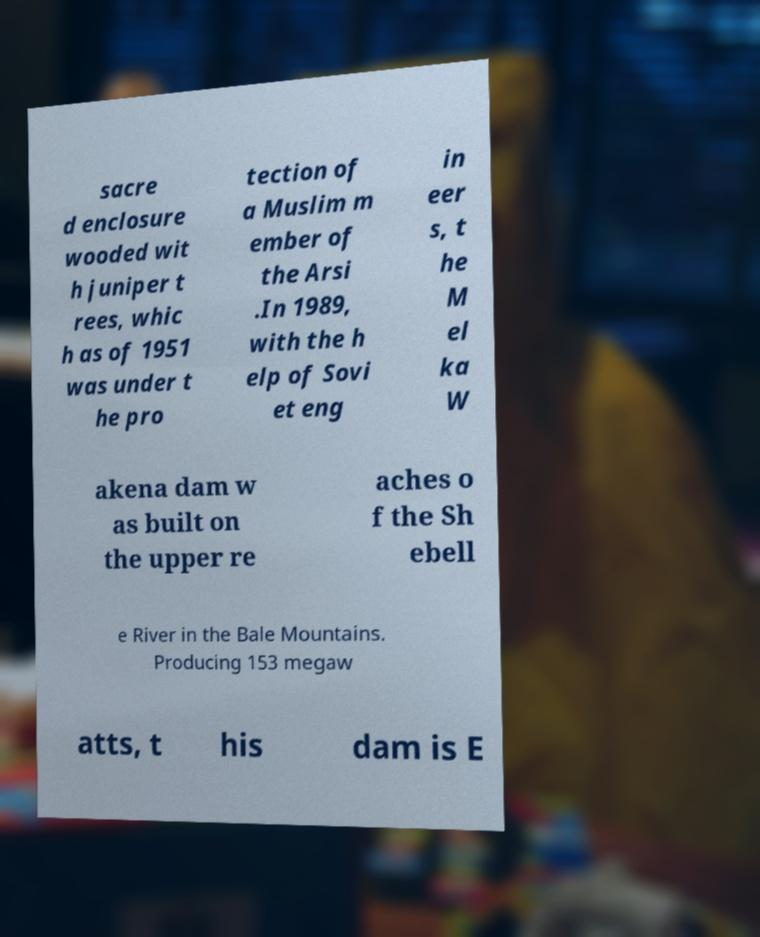Could you assist in decoding the text presented in this image and type it out clearly? sacre d enclosure wooded wit h juniper t rees, whic h as of 1951 was under t he pro tection of a Muslim m ember of the Arsi .In 1989, with the h elp of Sovi et eng in eer s, t he M el ka W akena dam w as built on the upper re aches o f the Sh ebell e River in the Bale Mountains. Producing 153 megaw atts, t his dam is E 